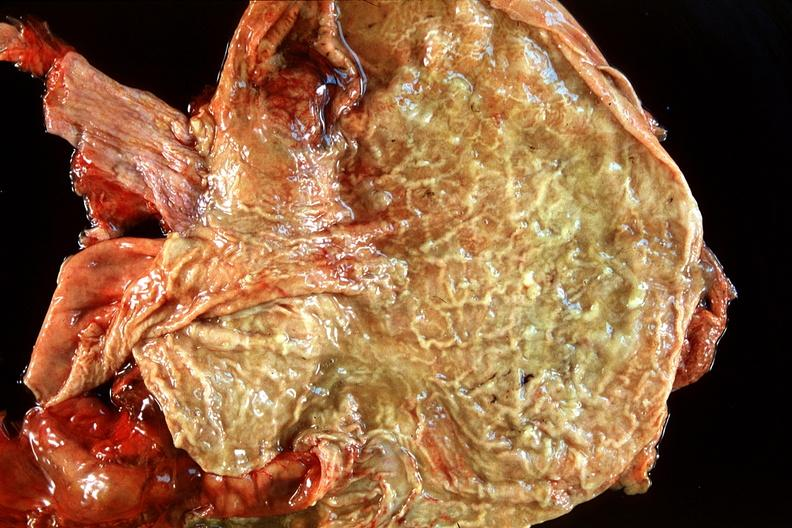does this image show normal stomach?
Answer the question using a single word or phrase. Yes 